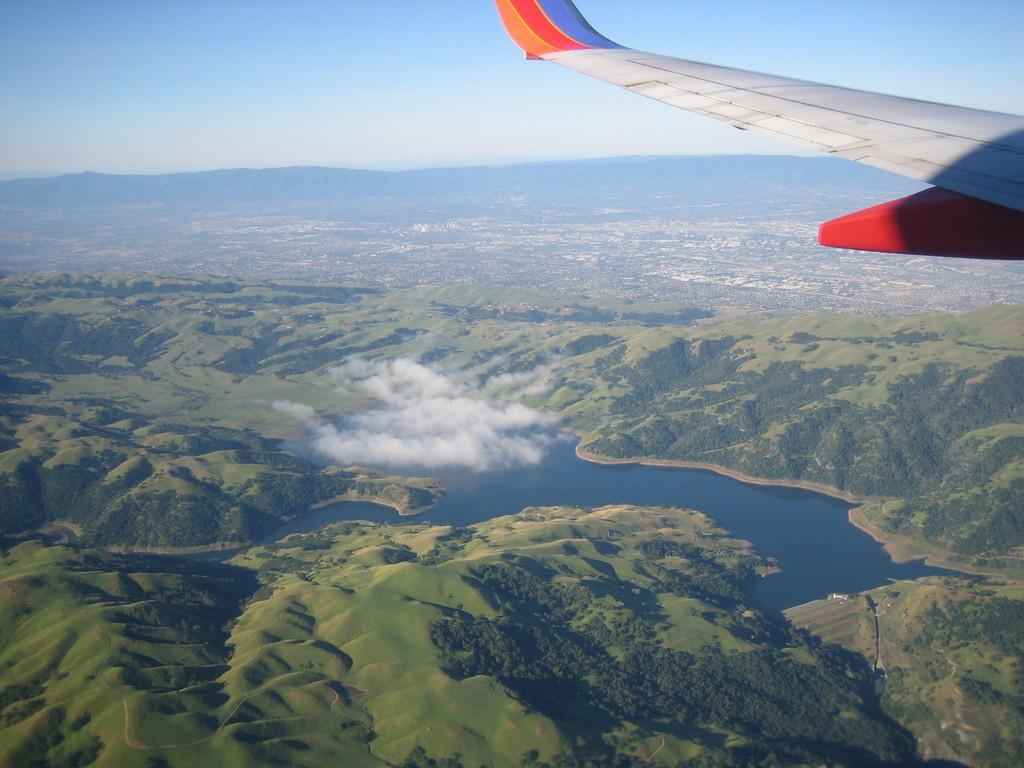Describe this image in one or two sentences. The image is taken from an airplane. In the foreground we can see airplane wing. In this picture there are hills, trees, clouds and a water body. In the foreground there are trees, hills and sky. 